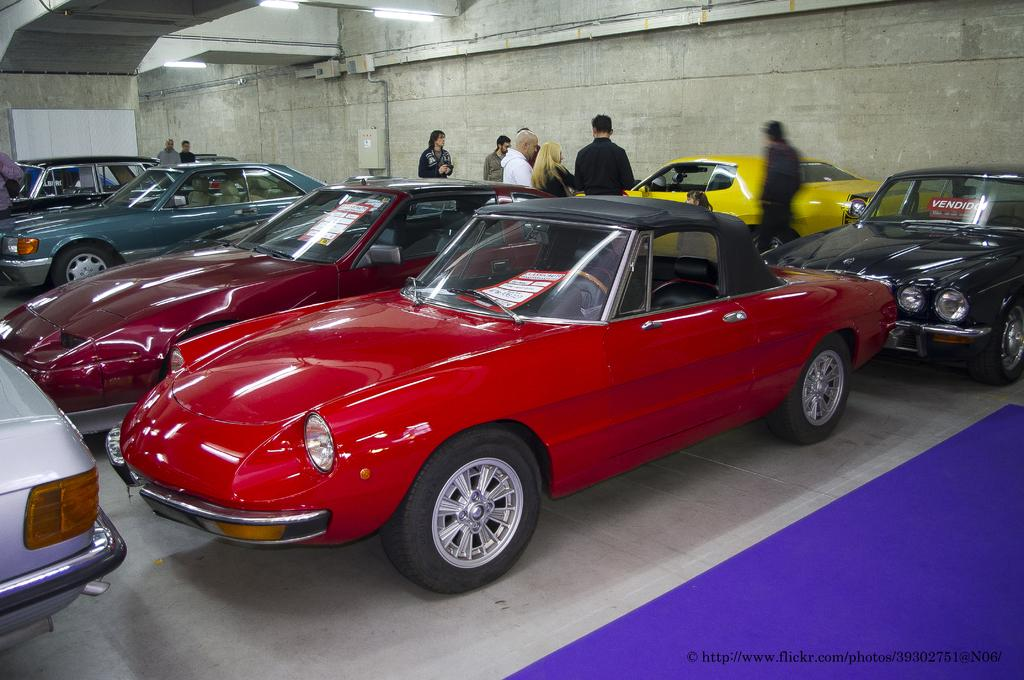What type of vehicles can be seen in the image? There are cars in the image. What else is present in the image besides the cars? There are people standing in the image. What is the purpose of the wall in the image? The wall's purpose is not specified in the image, but it could be a boundary or a part of a building. What type of patch is sewn onto the owl's wing in the image? There is no owl present in the image, so there is no patch on its wing. 